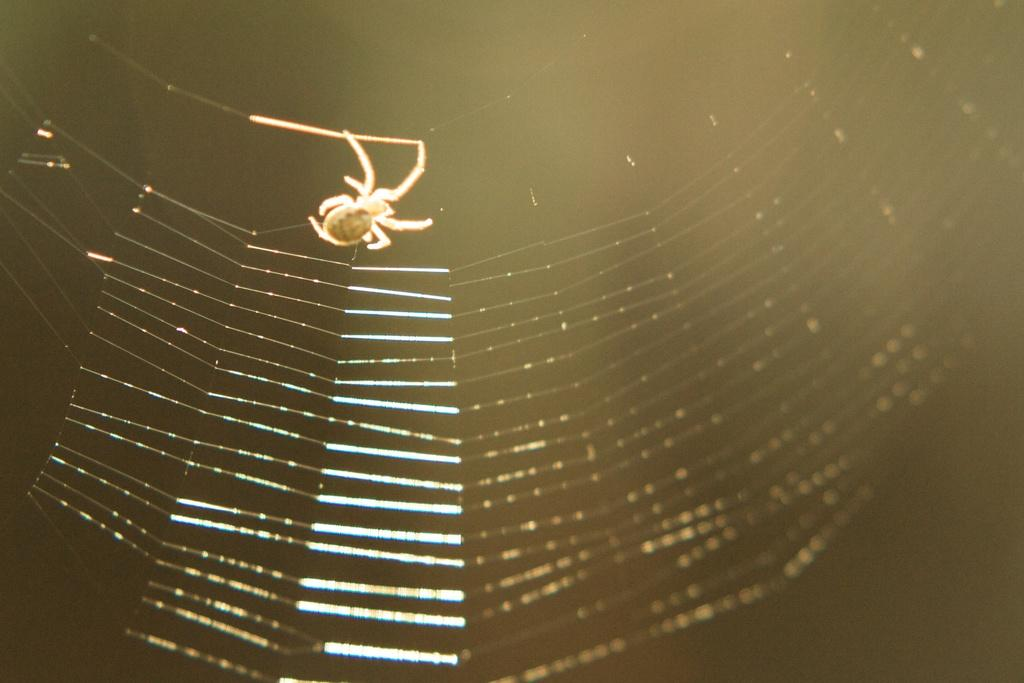What type of creature is in the image? There is a Spyder in the image. What does the Spyder have in the image? The Spyder has a web in the image. Where are the kittens playing in the image? There are no kittens present in the image; it features a Spyder with a web. How many ducks can be seen swimming in the image? There are no ducks present in the image; it features a Spyder with a web. 